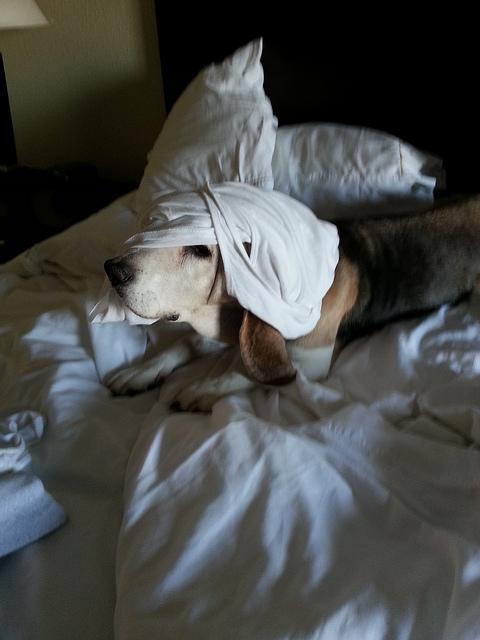What kind of dog is this?
Give a very brief answer. Beagle. What is covered with a blanket?
Quick response, please. Dog. Which animal or bird is on the bad?
Write a very short answer. Dog. Is this dog laying down?
Answer briefly. Yes. What is on his head?
Write a very short answer. Shirt. What is the dog laying on?
Write a very short answer. Bed. 